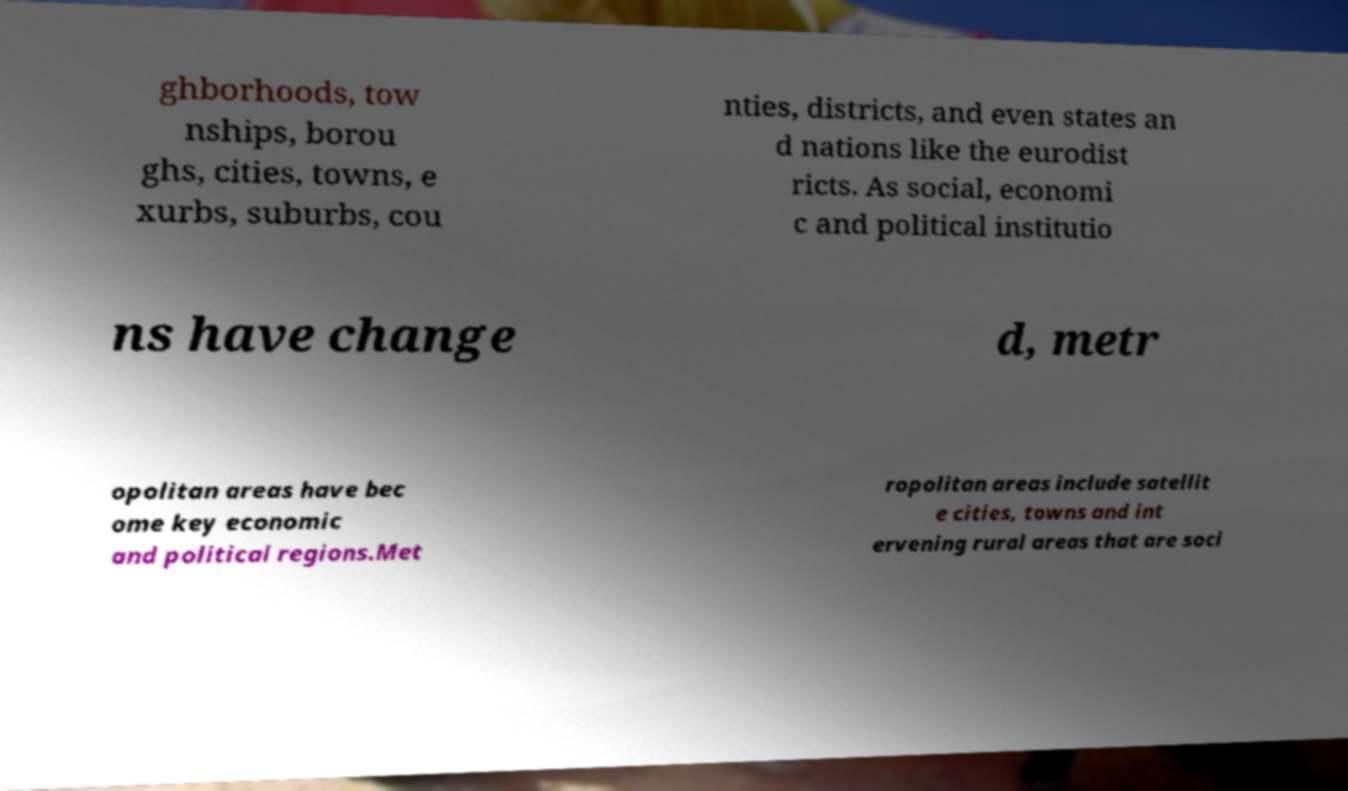Could you extract and type out the text from this image? ghborhoods, tow nships, borou ghs, cities, towns, e xurbs, suburbs, cou nties, districts, and even states an d nations like the eurodist ricts. As social, economi c and political institutio ns have change d, metr opolitan areas have bec ome key economic and political regions.Met ropolitan areas include satellit e cities, towns and int ervening rural areas that are soci 